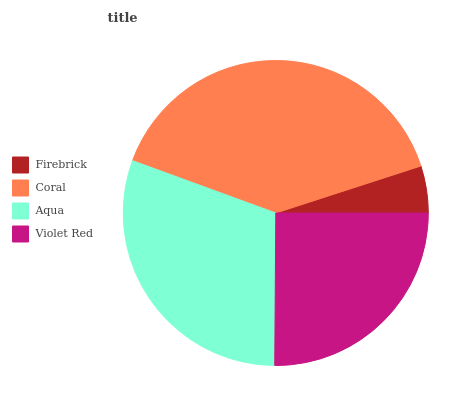Is Firebrick the minimum?
Answer yes or no. Yes. Is Coral the maximum?
Answer yes or no. Yes. Is Aqua the minimum?
Answer yes or no. No. Is Aqua the maximum?
Answer yes or no. No. Is Coral greater than Aqua?
Answer yes or no. Yes. Is Aqua less than Coral?
Answer yes or no. Yes. Is Aqua greater than Coral?
Answer yes or no. No. Is Coral less than Aqua?
Answer yes or no. No. Is Aqua the high median?
Answer yes or no. Yes. Is Violet Red the low median?
Answer yes or no. Yes. Is Firebrick the high median?
Answer yes or no. No. Is Aqua the low median?
Answer yes or no. No. 